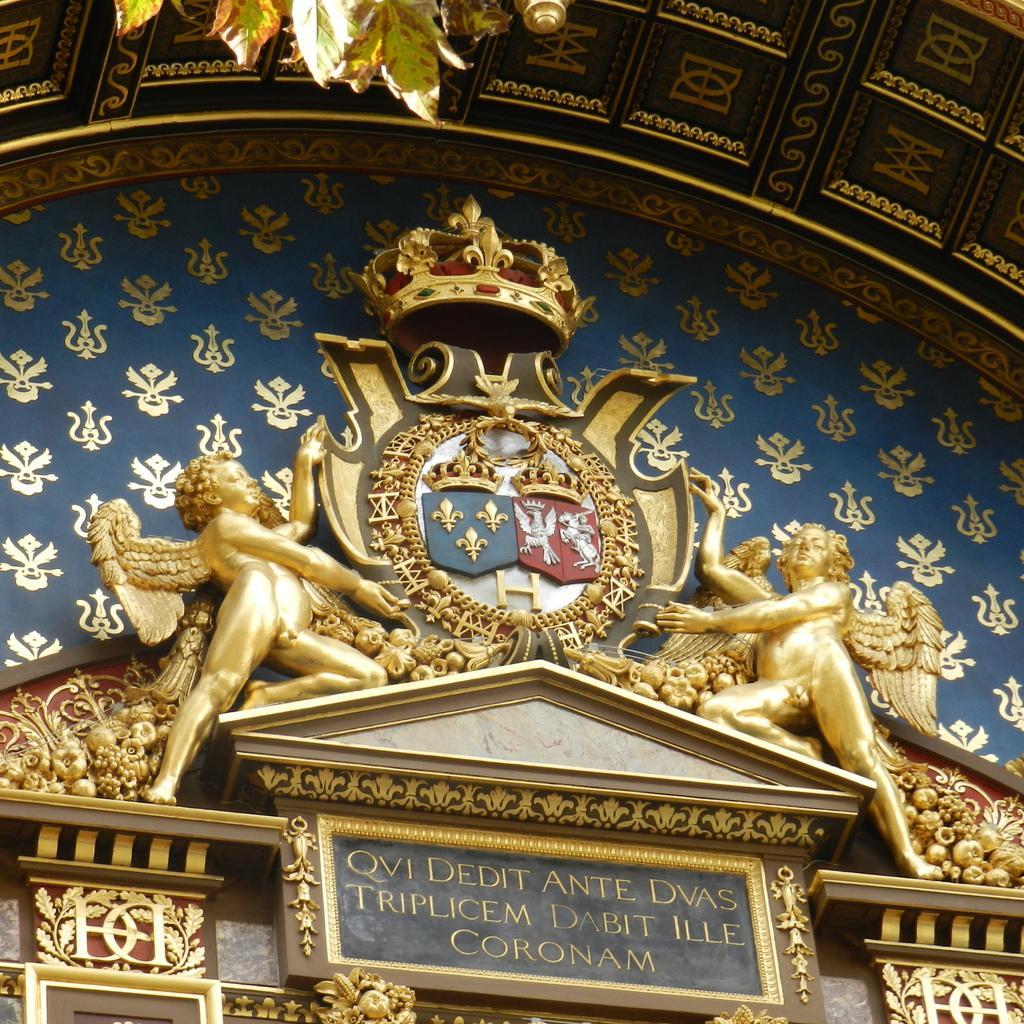Can you describe this image briefly? In this image there are two sculptures in the middle. In the middle there is a crown. In the background there is a wall on which there is a design. At the bottom there is a board on which there is some text. At the top there are leaves. 